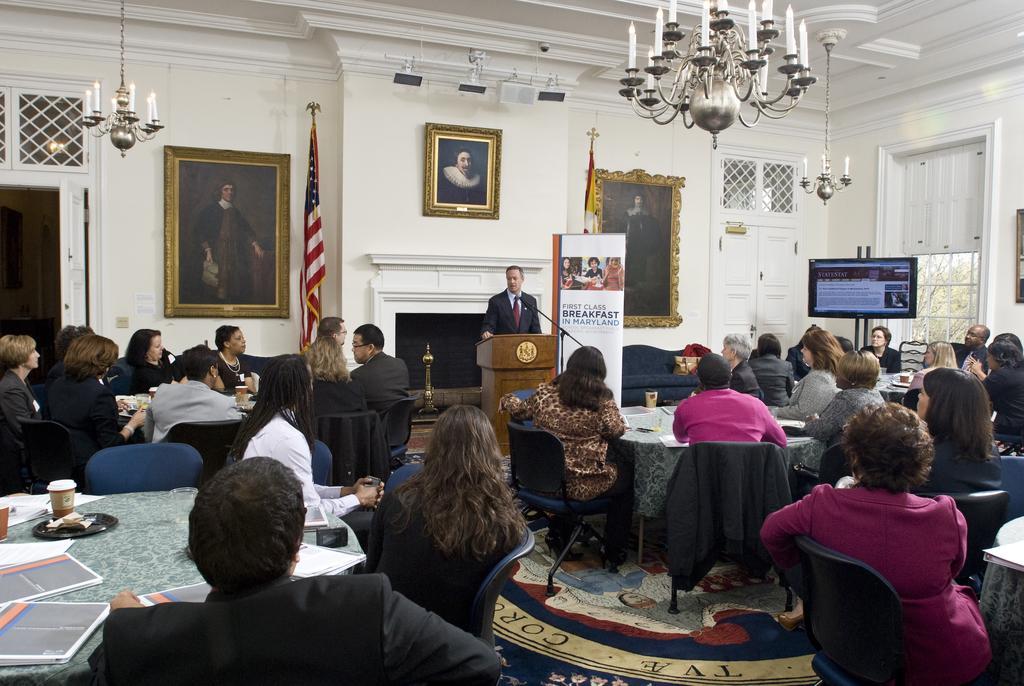In one or two sentences, can you explain what this image depicts? In this picture group of people sitting they have a table in front of them and is a person standing at the back side of the wooden stand, there is a flag here and there are photo frame kept on the wall and the television on the right side 